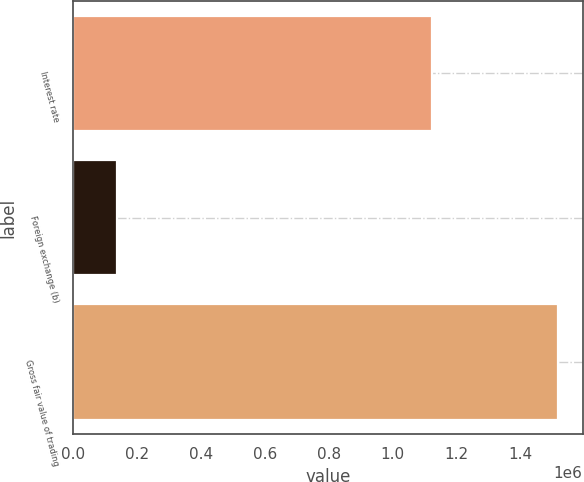<chart> <loc_0><loc_0><loc_500><loc_500><bar_chart><fcel>Interest rate<fcel>Foreign exchange (b)<fcel>Gross fair value of trading<nl><fcel>1.12198e+06<fcel>137865<fcel>1.51821e+06<nl></chart> 